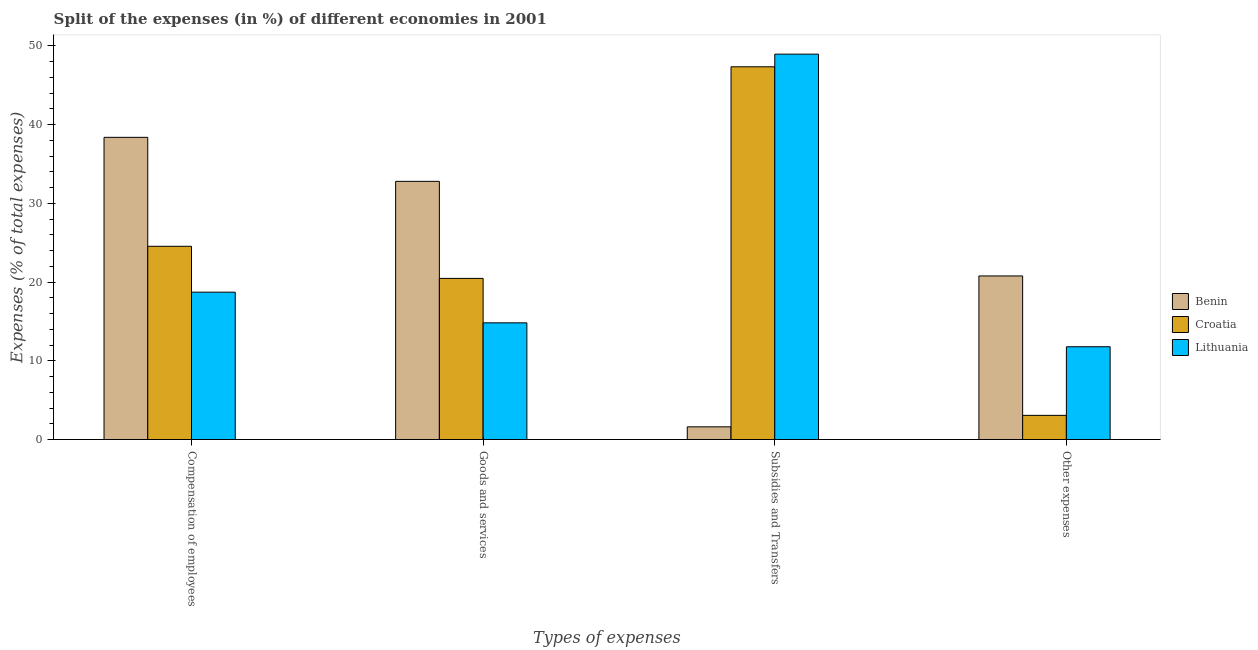How many different coloured bars are there?
Offer a terse response. 3. How many bars are there on the 4th tick from the left?
Offer a very short reply. 3. What is the label of the 2nd group of bars from the left?
Give a very brief answer. Goods and services. What is the percentage of amount spent on compensation of employees in Lithuania?
Ensure brevity in your answer.  18.73. Across all countries, what is the maximum percentage of amount spent on other expenses?
Ensure brevity in your answer.  20.79. Across all countries, what is the minimum percentage of amount spent on compensation of employees?
Keep it short and to the point. 18.73. In which country was the percentage of amount spent on compensation of employees maximum?
Offer a terse response. Benin. In which country was the percentage of amount spent on goods and services minimum?
Provide a succinct answer. Lithuania. What is the total percentage of amount spent on compensation of employees in the graph?
Give a very brief answer. 81.67. What is the difference between the percentage of amount spent on goods and services in Lithuania and that in Benin?
Make the answer very short. -17.97. What is the difference between the percentage of amount spent on other expenses in Croatia and the percentage of amount spent on subsidies in Lithuania?
Your answer should be compact. -45.88. What is the average percentage of amount spent on goods and services per country?
Ensure brevity in your answer.  22.7. What is the difference between the percentage of amount spent on compensation of employees and percentage of amount spent on goods and services in Croatia?
Ensure brevity in your answer.  4.08. In how many countries, is the percentage of amount spent on other expenses greater than 48 %?
Give a very brief answer. 0. What is the ratio of the percentage of amount spent on goods and services in Lithuania to that in Croatia?
Give a very brief answer. 0.72. Is the percentage of amount spent on compensation of employees in Croatia less than that in Benin?
Ensure brevity in your answer.  Yes. What is the difference between the highest and the second highest percentage of amount spent on subsidies?
Offer a terse response. 1.61. What is the difference between the highest and the lowest percentage of amount spent on other expenses?
Provide a short and direct response. 17.71. Is the sum of the percentage of amount spent on goods and services in Lithuania and Croatia greater than the maximum percentage of amount spent on other expenses across all countries?
Offer a very short reply. Yes. Is it the case that in every country, the sum of the percentage of amount spent on compensation of employees and percentage of amount spent on subsidies is greater than the sum of percentage of amount spent on other expenses and percentage of amount spent on goods and services?
Keep it short and to the point. No. What does the 2nd bar from the left in Compensation of employees represents?
Make the answer very short. Croatia. What does the 3rd bar from the right in Goods and services represents?
Your answer should be very brief. Benin. Is it the case that in every country, the sum of the percentage of amount spent on compensation of employees and percentage of amount spent on goods and services is greater than the percentage of amount spent on subsidies?
Make the answer very short. No. How many bars are there?
Give a very brief answer. 12. Are all the bars in the graph horizontal?
Offer a terse response. No. How many countries are there in the graph?
Keep it short and to the point. 3. Does the graph contain grids?
Make the answer very short. No. How many legend labels are there?
Provide a succinct answer. 3. What is the title of the graph?
Ensure brevity in your answer.  Split of the expenses (in %) of different economies in 2001. What is the label or title of the X-axis?
Your answer should be very brief. Types of expenses. What is the label or title of the Y-axis?
Your answer should be compact. Expenses (% of total expenses). What is the Expenses (% of total expenses) in Benin in Compensation of employees?
Provide a succinct answer. 38.39. What is the Expenses (% of total expenses) of Croatia in Compensation of employees?
Provide a short and direct response. 24.55. What is the Expenses (% of total expenses) of Lithuania in Compensation of employees?
Offer a terse response. 18.73. What is the Expenses (% of total expenses) of Benin in Goods and services?
Your answer should be compact. 32.8. What is the Expenses (% of total expenses) in Croatia in Goods and services?
Offer a terse response. 20.47. What is the Expenses (% of total expenses) in Lithuania in Goods and services?
Your answer should be compact. 14.83. What is the Expenses (% of total expenses) in Benin in Subsidies and Transfers?
Your answer should be very brief. 1.62. What is the Expenses (% of total expenses) of Croatia in Subsidies and Transfers?
Your answer should be compact. 47.35. What is the Expenses (% of total expenses) of Lithuania in Subsidies and Transfers?
Offer a terse response. 48.96. What is the Expenses (% of total expenses) in Benin in Other expenses?
Provide a succinct answer. 20.79. What is the Expenses (% of total expenses) in Croatia in Other expenses?
Keep it short and to the point. 3.08. What is the Expenses (% of total expenses) of Lithuania in Other expenses?
Ensure brevity in your answer.  11.79. Across all Types of expenses, what is the maximum Expenses (% of total expenses) of Benin?
Give a very brief answer. 38.39. Across all Types of expenses, what is the maximum Expenses (% of total expenses) of Croatia?
Your response must be concise. 47.35. Across all Types of expenses, what is the maximum Expenses (% of total expenses) in Lithuania?
Make the answer very short. 48.96. Across all Types of expenses, what is the minimum Expenses (% of total expenses) in Benin?
Provide a short and direct response. 1.62. Across all Types of expenses, what is the minimum Expenses (% of total expenses) of Croatia?
Offer a very short reply. 3.08. Across all Types of expenses, what is the minimum Expenses (% of total expenses) of Lithuania?
Your response must be concise. 11.79. What is the total Expenses (% of total expenses) of Benin in the graph?
Provide a short and direct response. 93.6. What is the total Expenses (% of total expenses) in Croatia in the graph?
Provide a short and direct response. 95.46. What is the total Expenses (% of total expenses) of Lithuania in the graph?
Give a very brief answer. 94.31. What is the difference between the Expenses (% of total expenses) in Benin in Compensation of employees and that in Goods and services?
Offer a very short reply. 5.59. What is the difference between the Expenses (% of total expenses) in Croatia in Compensation of employees and that in Goods and services?
Offer a very short reply. 4.08. What is the difference between the Expenses (% of total expenses) of Lithuania in Compensation of employees and that in Goods and services?
Keep it short and to the point. 3.89. What is the difference between the Expenses (% of total expenses) in Benin in Compensation of employees and that in Subsidies and Transfers?
Keep it short and to the point. 36.77. What is the difference between the Expenses (% of total expenses) of Croatia in Compensation of employees and that in Subsidies and Transfers?
Provide a short and direct response. -22.8. What is the difference between the Expenses (% of total expenses) of Lithuania in Compensation of employees and that in Subsidies and Transfers?
Keep it short and to the point. -30.23. What is the difference between the Expenses (% of total expenses) in Benin in Compensation of employees and that in Other expenses?
Ensure brevity in your answer.  17.61. What is the difference between the Expenses (% of total expenses) of Croatia in Compensation of employees and that in Other expenses?
Keep it short and to the point. 21.48. What is the difference between the Expenses (% of total expenses) in Lithuania in Compensation of employees and that in Other expenses?
Offer a terse response. 6.93. What is the difference between the Expenses (% of total expenses) in Benin in Goods and services and that in Subsidies and Transfers?
Offer a terse response. 31.18. What is the difference between the Expenses (% of total expenses) of Croatia in Goods and services and that in Subsidies and Transfers?
Ensure brevity in your answer.  -26.88. What is the difference between the Expenses (% of total expenses) of Lithuania in Goods and services and that in Subsidies and Transfers?
Provide a short and direct response. -34.13. What is the difference between the Expenses (% of total expenses) of Benin in Goods and services and that in Other expenses?
Your answer should be compact. 12.01. What is the difference between the Expenses (% of total expenses) of Croatia in Goods and services and that in Other expenses?
Ensure brevity in your answer.  17.4. What is the difference between the Expenses (% of total expenses) in Lithuania in Goods and services and that in Other expenses?
Provide a short and direct response. 3.04. What is the difference between the Expenses (% of total expenses) in Benin in Subsidies and Transfers and that in Other expenses?
Provide a short and direct response. -19.16. What is the difference between the Expenses (% of total expenses) of Croatia in Subsidies and Transfers and that in Other expenses?
Provide a succinct answer. 44.27. What is the difference between the Expenses (% of total expenses) in Lithuania in Subsidies and Transfers and that in Other expenses?
Offer a terse response. 37.16. What is the difference between the Expenses (% of total expenses) of Benin in Compensation of employees and the Expenses (% of total expenses) of Croatia in Goods and services?
Your response must be concise. 17.92. What is the difference between the Expenses (% of total expenses) in Benin in Compensation of employees and the Expenses (% of total expenses) in Lithuania in Goods and services?
Ensure brevity in your answer.  23.56. What is the difference between the Expenses (% of total expenses) in Croatia in Compensation of employees and the Expenses (% of total expenses) in Lithuania in Goods and services?
Give a very brief answer. 9.72. What is the difference between the Expenses (% of total expenses) of Benin in Compensation of employees and the Expenses (% of total expenses) of Croatia in Subsidies and Transfers?
Offer a very short reply. -8.96. What is the difference between the Expenses (% of total expenses) in Benin in Compensation of employees and the Expenses (% of total expenses) in Lithuania in Subsidies and Transfers?
Make the answer very short. -10.57. What is the difference between the Expenses (% of total expenses) in Croatia in Compensation of employees and the Expenses (% of total expenses) in Lithuania in Subsidies and Transfers?
Offer a terse response. -24.4. What is the difference between the Expenses (% of total expenses) of Benin in Compensation of employees and the Expenses (% of total expenses) of Croatia in Other expenses?
Your answer should be very brief. 35.31. What is the difference between the Expenses (% of total expenses) in Benin in Compensation of employees and the Expenses (% of total expenses) in Lithuania in Other expenses?
Provide a short and direct response. 26.6. What is the difference between the Expenses (% of total expenses) in Croatia in Compensation of employees and the Expenses (% of total expenses) in Lithuania in Other expenses?
Your answer should be very brief. 12.76. What is the difference between the Expenses (% of total expenses) in Benin in Goods and services and the Expenses (% of total expenses) in Croatia in Subsidies and Transfers?
Ensure brevity in your answer.  -14.55. What is the difference between the Expenses (% of total expenses) of Benin in Goods and services and the Expenses (% of total expenses) of Lithuania in Subsidies and Transfers?
Give a very brief answer. -16.16. What is the difference between the Expenses (% of total expenses) in Croatia in Goods and services and the Expenses (% of total expenses) in Lithuania in Subsidies and Transfers?
Offer a very short reply. -28.48. What is the difference between the Expenses (% of total expenses) of Benin in Goods and services and the Expenses (% of total expenses) of Croatia in Other expenses?
Keep it short and to the point. 29.72. What is the difference between the Expenses (% of total expenses) of Benin in Goods and services and the Expenses (% of total expenses) of Lithuania in Other expenses?
Offer a terse response. 21.01. What is the difference between the Expenses (% of total expenses) in Croatia in Goods and services and the Expenses (% of total expenses) in Lithuania in Other expenses?
Make the answer very short. 8.68. What is the difference between the Expenses (% of total expenses) in Benin in Subsidies and Transfers and the Expenses (% of total expenses) in Croatia in Other expenses?
Keep it short and to the point. -1.46. What is the difference between the Expenses (% of total expenses) in Benin in Subsidies and Transfers and the Expenses (% of total expenses) in Lithuania in Other expenses?
Your answer should be compact. -10.17. What is the difference between the Expenses (% of total expenses) in Croatia in Subsidies and Transfers and the Expenses (% of total expenses) in Lithuania in Other expenses?
Offer a terse response. 35.56. What is the average Expenses (% of total expenses) of Benin per Types of expenses?
Ensure brevity in your answer.  23.4. What is the average Expenses (% of total expenses) in Croatia per Types of expenses?
Give a very brief answer. 23.86. What is the average Expenses (% of total expenses) of Lithuania per Types of expenses?
Provide a short and direct response. 23.58. What is the difference between the Expenses (% of total expenses) in Benin and Expenses (% of total expenses) in Croatia in Compensation of employees?
Provide a short and direct response. 13.84. What is the difference between the Expenses (% of total expenses) in Benin and Expenses (% of total expenses) in Lithuania in Compensation of employees?
Your response must be concise. 19.67. What is the difference between the Expenses (% of total expenses) of Croatia and Expenses (% of total expenses) of Lithuania in Compensation of employees?
Ensure brevity in your answer.  5.83. What is the difference between the Expenses (% of total expenses) of Benin and Expenses (% of total expenses) of Croatia in Goods and services?
Offer a terse response. 12.33. What is the difference between the Expenses (% of total expenses) in Benin and Expenses (% of total expenses) in Lithuania in Goods and services?
Give a very brief answer. 17.97. What is the difference between the Expenses (% of total expenses) of Croatia and Expenses (% of total expenses) of Lithuania in Goods and services?
Your response must be concise. 5.64. What is the difference between the Expenses (% of total expenses) of Benin and Expenses (% of total expenses) of Croatia in Subsidies and Transfers?
Your answer should be compact. -45.73. What is the difference between the Expenses (% of total expenses) in Benin and Expenses (% of total expenses) in Lithuania in Subsidies and Transfers?
Offer a very short reply. -47.34. What is the difference between the Expenses (% of total expenses) in Croatia and Expenses (% of total expenses) in Lithuania in Subsidies and Transfers?
Offer a terse response. -1.61. What is the difference between the Expenses (% of total expenses) in Benin and Expenses (% of total expenses) in Croatia in Other expenses?
Offer a very short reply. 17.71. What is the difference between the Expenses (% of total expenses) in Benin and Expenses (% of total expenses) in Lithuania in Other expenses?
Provide a short and direct response. 8.99. What is the difference between the Expenses (% of total expenses) in Croatia and Expenses (% of total expenses) in Lithuania in Other expenses?
Make the answer very short. -8.72. What is the ratio of the Expenses (% of total expenses) in Benin in Compensation of employees to that in Goods and services?
Offer a terse response. 1.17. What is the ratio of the Expenses (% of total expenses) in Croatia in Compensation of employees to that in Goods and services?
Provide a short and direct response. 1.2. What is the ratio of the Expenses (% of total expenses) of Lithuania in Compensation of employees to that in Goods and services?
Your response must be concise. 1.26. What is the ratio of the Expenses (% of total expenses) in Benin in Compensation of employees to that in Subsidies and Transfers?
Your response must be concise. 23.67. What is the ratio of the Expenses (% of total expenses) of Croatia in Compensation of employees to that in Subsidies and Transfers?
Your answer should be very brief. 0.52. What is the ratio of the Expenses (% of total expenses) of Lithuania in Compensation of employees to that in Subsidies and Transfers?
Offer a terse response. 0.38. What is the ratio of the Expenses (% of total expenses) of Benin in Compensation of employees to that in Other expenses?
Your response must be concise. 1.85. What is the ratio of the Expenses (% of total expenses) of Croatia in Compensation of employees to that in Other expenses?
Offer a very short reply. 7.98. What is the ratio of the Expenses (% of total expenses) in Lithuania in Compensation of employees to that in Other expenses?
Your answer should be very brief. 1.59. What is the ratio of the Expenses (% of total expenses) of Benin in Goods and services to that in Subsidies and Transfers?
Make the answer very short. 20.22. What is the ratio of the Expenses (% of total expenses) of Croatia in Goods and services to that in Subsidies and Transfers?
Offer a terse response. 0.43. What is the ratio of the Expenses (% of total expenses) in Lithuania in Goods and services to that in Subsidies and Transfers?
Provide a succinct answer. 0.3. What is the ratio of the Expenses (% of total expenses) in Benin in Goods and services to that in Other expenses?
Your answer should be very brief. 1.58. What is the ratio of the Expenses (% of total expenses) in Croatia in Goods and services to that in Other expenses?
Keep it short and to the point. 6.65. What is the ratio of the Expenses (% of total expenses) of Lithuania in Goods and services to that in Other expenses?
Offer a terse response. 1.26. What is the ratio of the Expenses (% of total expenses) of Benin in Subsidies and Transfers to that in Other expenses?
Your answer should be compact. 0.08. What is the ratio of the Expenses (% of total expenses) in Croatia in Subsidies and Transfers to that in Other expenses?
Make the answer very short. 15.38. What is the ratio of the Expenses (% of total expenses) in Lithuania in Subsidies and Transfers to that in Other expenses?
Keep it short and to the point. 4.15. What is the difference between the highest and the second highest Expenses (% of total expenses) of Benin?
Ensure brevity in your answer.  5.59. What is the difference between the highest and the second highest Expenses (% of total expenses) of Croatia?
Your answer should be very brief. 22.8. What is the difference between the highest and the second highest Expenses (% of total expenses) in Lithuania?
Your answer should be compact. 30.23. What is the difference between the highest and the lowest Expenses (% of total expenses) in Benin?
Offer a very short reply. 36.77. What is the difference between the highest and the lowest Expenses (% of total expenses) in Croatia?
Give a very brief answer. 44.27. What is the difference between the highest and the lowest Expenses (% of total expenses) of Lithuania?
Provide a succinct answer. 37.16. 